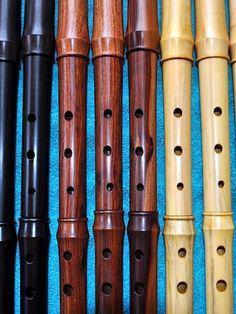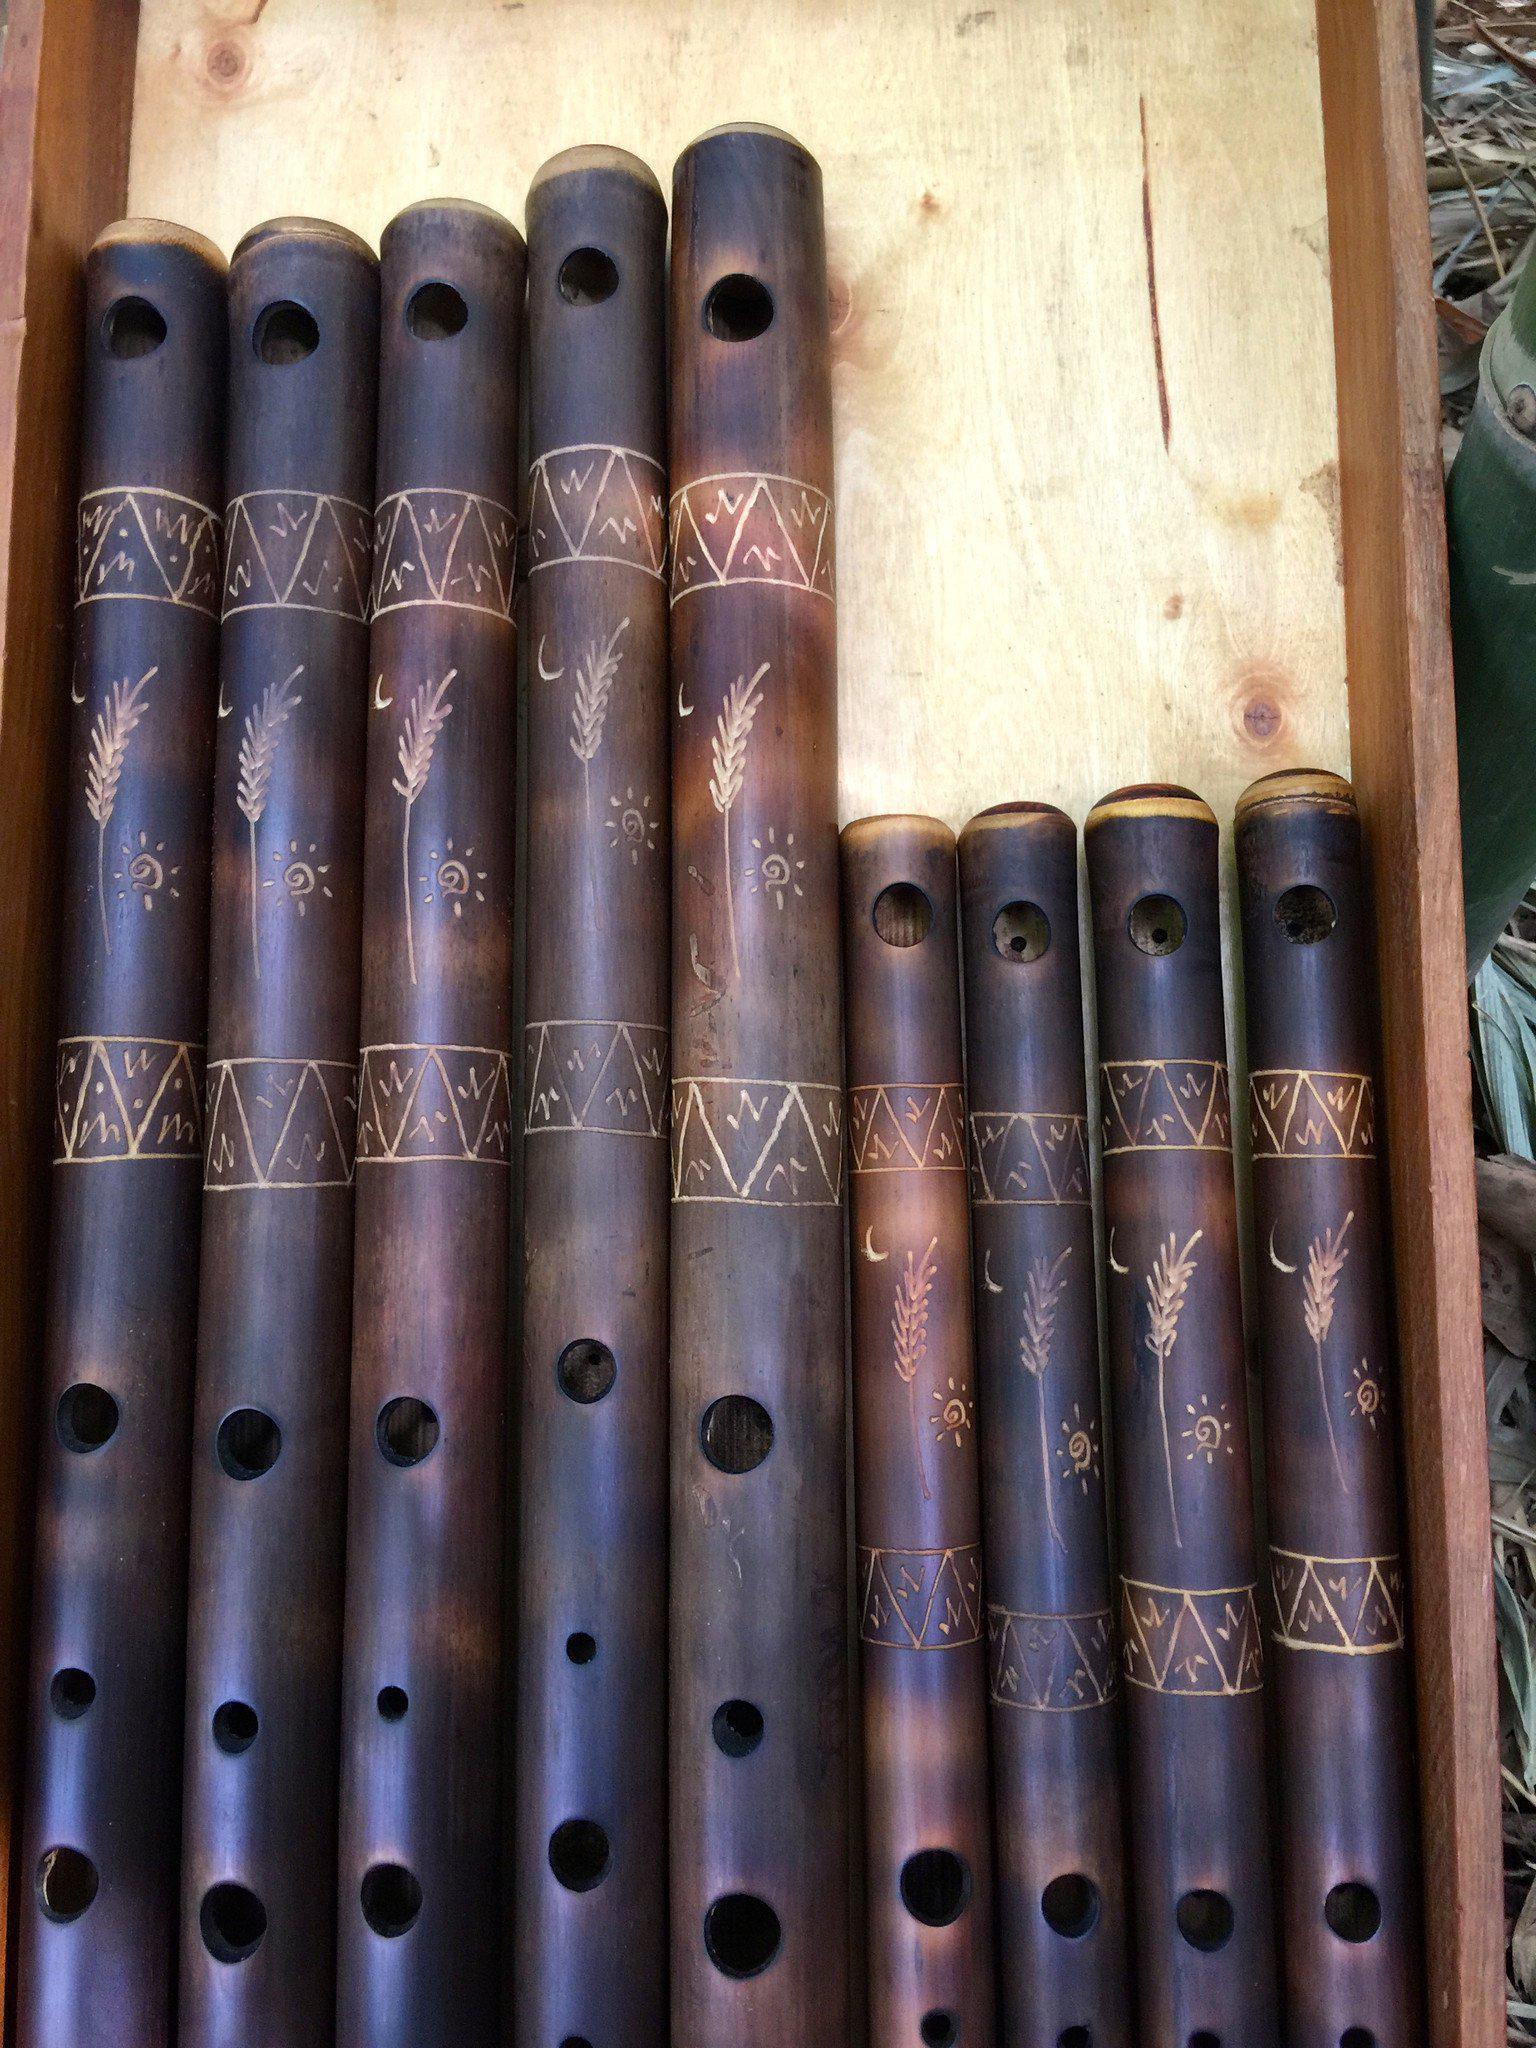The first image is the image on the left, the second image is the image on the right. For the images displayed, is the sentence "The right image shows a rustic curved wooden flute with brown straps at its top, and it is displayed end-first." factually correct? Answer yes or no. No. The first image is the image on the left, the second image is the image on the right. Examine the images to the left and right. Is the description "There are less than three instruments in the right image." accurate? Answer yes or no. No. 